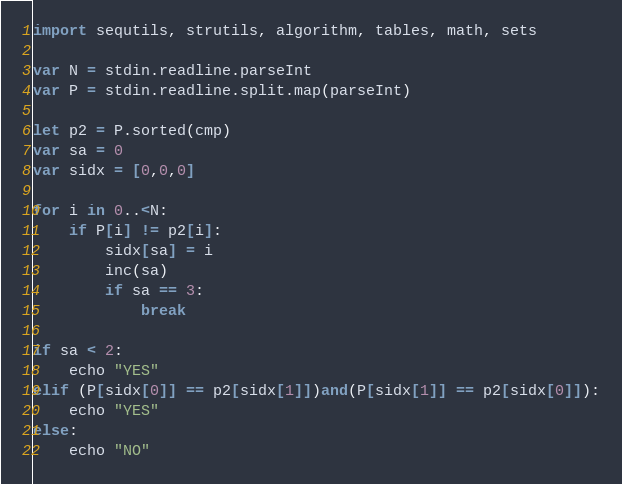Convert code to text. <code><loc_0><loc_0><loc_500><loc_500><_Nim_>import sequtils, strutils, algorithm, tables, math, sets

var N = stdin.readline.parseInt
var P = stdin.readline.split.map(parseInt)

let p2 = P.sorted(cmp)
var sa = 0
var sidx = [0,0,0]

for i in 0..<N:
    if P[i] != p2[i]:
        sidx[sa] = i
        inc(sa)
        if sa == 3:
            break

if sa < 2:
    echo "YES"
elif (P[sidx[0]] == p2[sidx[1]])and(P[sidx[1]] == p2[sidx[0]]):
    echo "YES"
else:
    echo "NO"</code> 